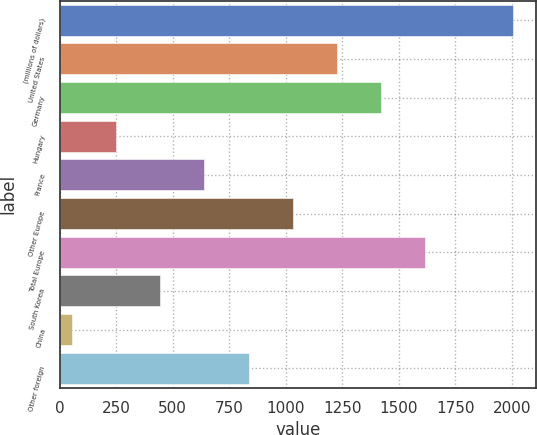Convert chart. <chart><loc_0><loc_0><loc_500><loc_500><bar_chart><fcel>(millions of dollars)<fcel>United States<fcel>Germany<fcel>Hungary<fcel>France<fcel>Other Europe<fcel>Total Europe<fcel>South Korea<fcel>China<fcel>Other foreign<nl><fcel>2008<fcel>1226.84<fcel>1422.13<fcel>250.39<fcel>640.97<fcel>1031.55<fcel>1617.42<fcel>445.68<fcel>55.1<fcel>836.26<nl></chart> 